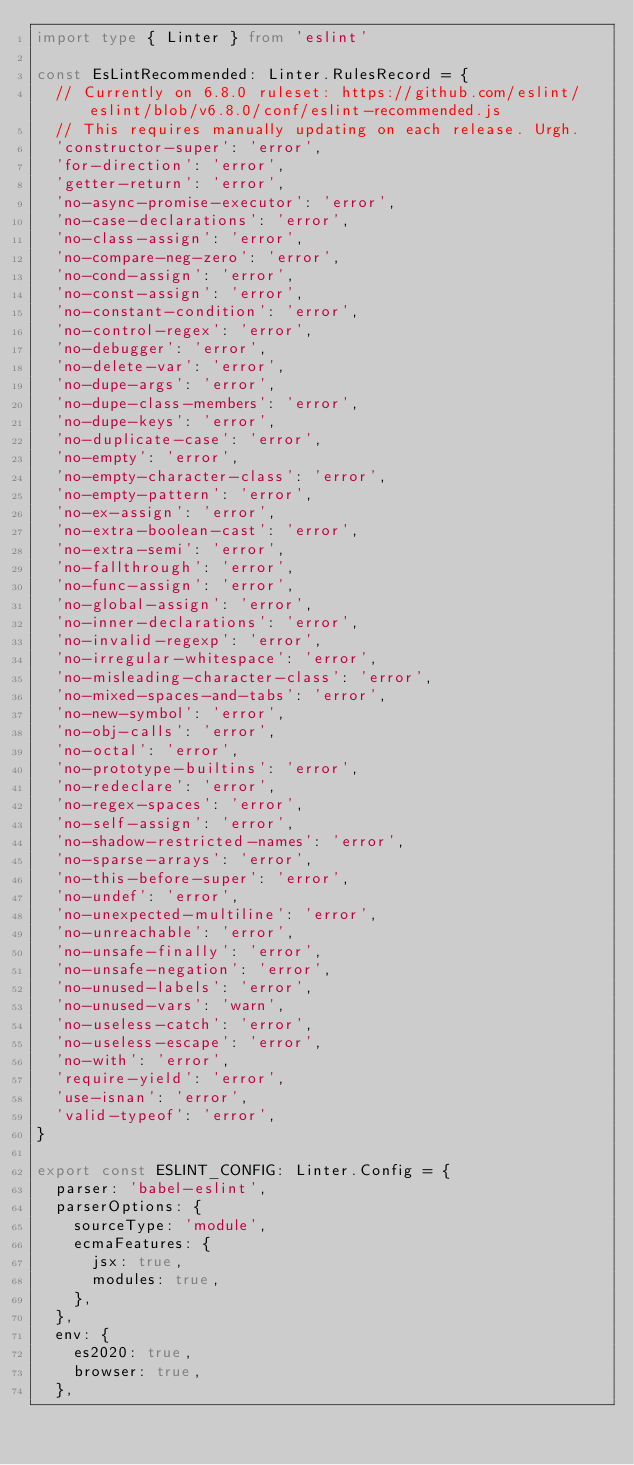Convert code to text. <code><loc_0><loc_0><loc_500><loc_500><_TypeScript_>import type { Linter } from 'eslint'

const EsLintRecommended: Linter.RulesRecord = {
  // Currently on 6.8.0 ruleset: https://github.com/eslint/eslint/blob/v6.8.0/conf/eslint-recommended.js
  // This requires manually updating on each release. Urgh.
  'constructor-super': 'error',
  'for-direction': 'error',
  'getter-return': 'error',
  'no-async-promise-executor': 'error',
  'no-case-declarations': 'error',
  'no-class-assign': 'error',
  'no-compare-neg-zero': 'error',
  'no-cond-assign': 'error',
  'no-const-assign': 'error',
  'no-constant-condition': 'error',
  'no-control-regex': 'error',
  'no-debugger': 'error',
  'no-delete-var': 'error',
  'no-dupe-args': 'error',
  'no-dupe-class-members': 'error',
  'no-dupe-keys': 'error',
  'no-duplicate-case': 'error',
  'no-empty': 'error',
  'no-empty-character-class': 'error',
  'no-empty-pattern': 'error',
  'no-ex-assign': 'error',
  'no-extra-boolean-cast': 'error',
  'no-extra-semi': 'error',
  'no-fallthrough': 'error',
  'no-func-assign': 'error',
  'no-global-assign': 'error',
  'no-inner-declarations': 'error',
  'no-invalid-regexp': 'error',
  'no-irregular-whitespace': 'error',
  'no-misleading-character-class': 'error',
  'no-mixed-spaces-and-tabs': 'error',
  'no-new-symbol': 'error',
  'no-obj-calls': 'error',
  'no-octal': 'error',
  'no-prototype-builtins': 'error',
  'no-redeclare': 'error',
  'no-regex-spaces': 'error',
  'no-self-assign': 'error',
  'no-shadow-restricted-names': 'error',
  'no-sparse-arrays': 'error',
  'no-this-before-super': 'error',
  'no-undef': 'error',
  'no-unexpected-multiline': 'error',
  'no-unreachable': 'error',
  'no-unsafe-finally': 'error',
  'no-unsafe-negation': 'error',
  'no-unused-labels': 'error',
  'no-unused-vars': 'warn',
  'no-useless-catch': 'error',
  'no-useless-escape': 'error',
  'no-with': 'error',
  'require-yield': 'error',
  'use-isnan': 'error',
  'valid-typeof': 'error',
}

export const ESLINT_CONFIG: Linter.Config = {
  parser: 'babel-eslint',
  parserOptions: {
    sourceType: 'module',
    ecmaFeatures: {
      jsx: true,
      modules: true,
    },
  },
  env: {
    es2020: true,
    browser: true,
  },</code> 